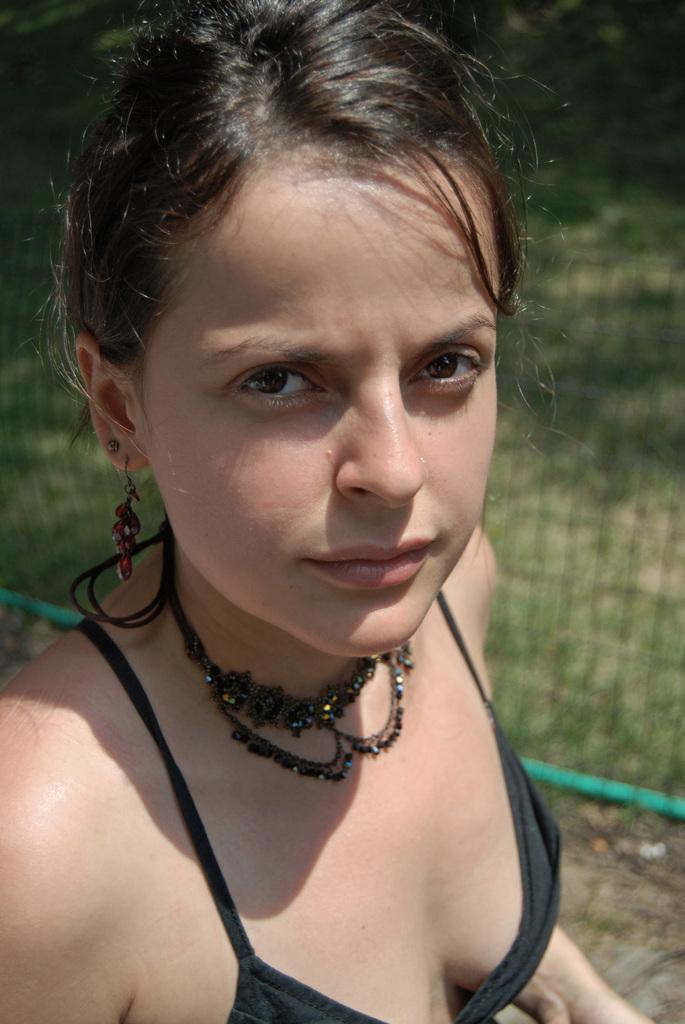In one or two sentences, can you explain what this image depicts? In the background we can see green grass, net. In this picture we can see a woman wearing a necklace. 